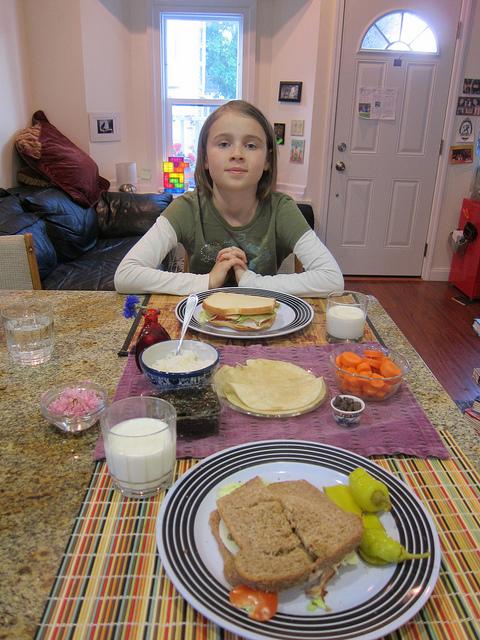Are they eating sandwiches?
Give a very brief answer. Yes. What kind of bread is the sandwich made of?
Short answer required. Wheat. Is this a nice restaurant?
Keep it brief. No. What is the girl having to drink?
Write a very short answer. Milk. What type of restaurant would serve this dish?
Write a very short answer. Home. 